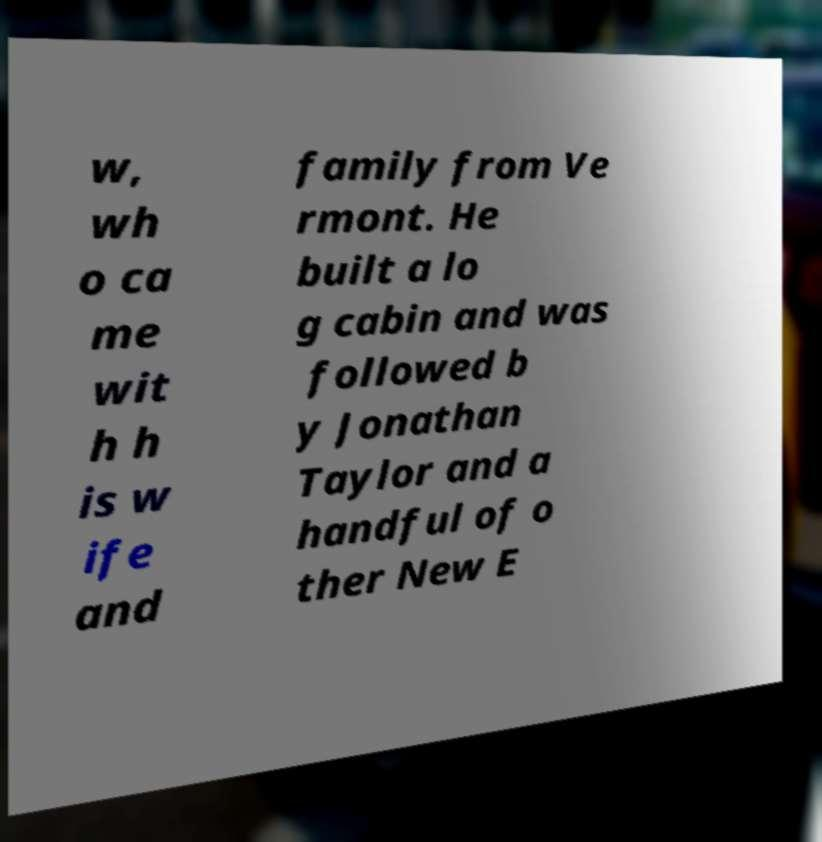Can you read and provide the text displayed in the image?This photo seems to have some interesting text. Can you extract and type it out for me? w, wh o ca me wit h h is w ife and family from Ve rmont. He built a lo g cabin and was followed b y Jonathan Taylor and a handful of o ther New E 